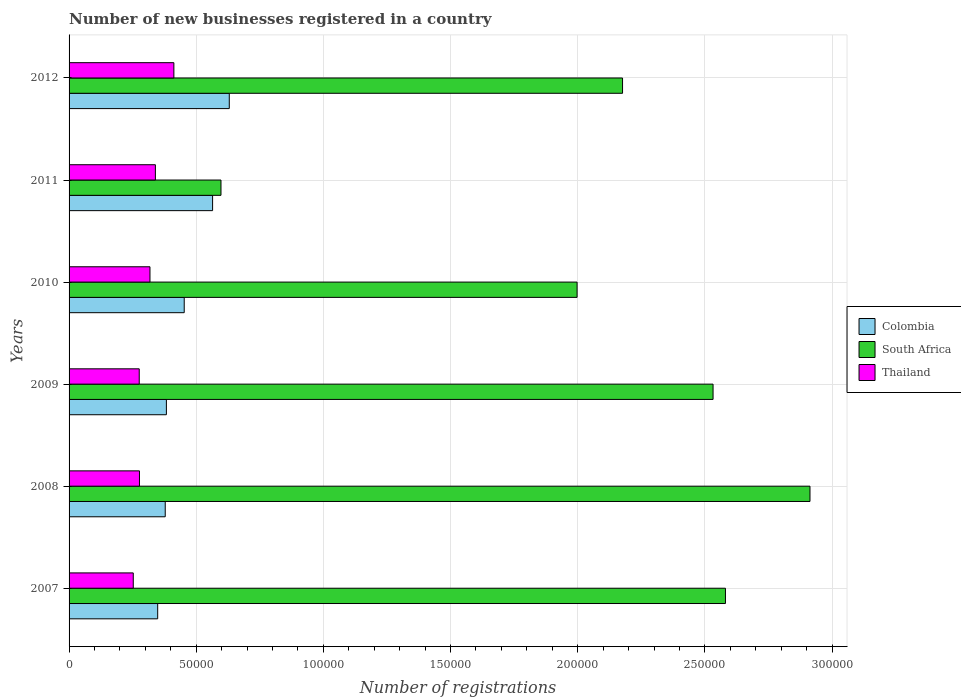Are the number of bars per tick equal to the number of legend labels?
Give a very brief answer. Yes. Are the number of bars on each tick of the Y-axis equal?
Provide a succinct answer. Yes. How many bars are there on the 6th tick from the top?
Your answer should be compact. 3. In how many cases, is the number of bars for a given year not equal to the number of legend labels?
Ensure brevity in your answer.  0. What is the number of new businesses registered in Colombia in 2009?
Provide a succinct answer. 3.83e+04. Across all years, what is the maximum number of new businesses registered in Colombia?
Provide a short and direct response. 6.30e+04. Across all years, what is the minimum number of new businesses registered in Thailand?
Make the answer very short. 2.52e+04. In which year was the number of new businesses registered in South Africa maximum?
Ensure brevity in your answer.  2008. What is the total number of new businesses registered in South Africa in the graph?
Give a very brief answer. 1.28e+06. What is the difference between the number of new businesses registered in Colombia in 2008 and that in 2012?
Your answer should be compact. -2.52e+04. What is the difference between the number of new businesses registered in Colombia in 2010 and the number of new businesses registered in Thailand in 2011?
Your answer should be compact. 1.13e+04. What is the average number of new businesses registered in South Africa per year?
Keep it short and to the point. 2.13e+05. In the year 2007, what is the difference between the number of new businesses registered in Thailand and number of new businesses registered in Colombia?
Offer a very short reply. -9602. What is the ratio of the number of new businesses registered in South Africa in 2010 to that in 2011?
Your answer should be compact. 3.34. Is the number of new businesses registered in South Africa in 2009 less than that in 2011?
Give a very brief answer. No. What is the difference between the highest and the second highest number of new businesses registered in South Africa?
Your answer should be very brief. 3.32e+04. What is the difference between the highest and the lowest number of new businesses registered in Colombia?
Provide a short and direct response. 2.82e+04. In how many years, is the number of new businesses registered in Colombia greater than the average number of new businesses registered in Colombia taken over all years?
Offer a terse response. 2. What does the 1st bar from the top in 2012 represents?
Provide a short and direct response. Thailand. What does the 1st bar from the bottom in 2012 represents?
Provide a succinct answer. Colombia. What is the difference between two consecutive major ticks on the X-axis?
Keep it short and to the point. 5.00e+04. Does the graph contain any zero values?
Make the answer very short. No. Does the graph contain grids?
Give a very brief answer. Yes. How are the legend labels stacked?
Give a very brief answer. Vertical. What is the title of the graph?
Make the answer very short. Number of new businesses registered in a country. Does "Comoros" appear as one of the legend labels in the graph?
Make the answer very short. No. What is the label or title of the X-axis?
Your answer should be compact. Number of registrations. What is the Number of registrations of Colombia in 2007?
Provide a succinct answer. 3.48e+04. What is the Number of registrations of South Africa in 2007?
Give a very brief answer. 2.58e+05. What is the Number of registrations in Thailand in 2007?
Your response must be concise. 2.52e+04. What is the Number of registrations of Colombia in 2008?
Provide a succinct answer. 3.78e+04. What is the Number of registrations of South Africa in 2008?
Your answer should be compact. 2.91e+05. What is the Number of registrations in Thailand in 2008?
Your answer should be compact. 2.77e+04. What is the Number of registrations in Colombia in 2009?
Ensure brevity in your answer.  3.83e+04. What is the Number of registrations in South Africa in 2009?
Your answer should be compact. 2.53e+05. What is the Number of registrations of Thailand in 2009?
Your answer should be very brief. 2.76e+04. What is the Number of registrations in Colombia in 2010?
Your answer should be very brief. 4.53e+04. What is the Number of registrations in South Africa in 2010?
Your response must be concise. 2.00e+05. What is the Number of registrations of Thailand in 2010?
Provide a short and direct response. 3.18e+04. What is the Number of registrations of Colombia in 2011?
Give a very brief answer. 5.64e+04. What is the Number of registrations of South Africa in 2011?
Ensure brevity in your answer.  5.97e+04. What is the Number of registrations of Thailand in 2011?
Offer a very short reply. 3.39e+04. What is the Number of registrations of Colombia in 2012?
Keep it short and to the point. 6.30e+04. What is the Number of registrations in South Africa in 2012?
Make the answer very short. 2.18e+05. What is the Number of registrations of Thailand in 2012?
Your answer should be very brief. 4.12e+04. Across all years, what is the maximum Number of registrations of Colombia?
Offer a terse response. 6.30e+04. Across all years, what is the maximum Number of registrations in South Africa?
Your answer should be compact. 2.91e+05. Across all years, what is the maximum Number of registrations in Thailand?
Your answer should be very brief. 4.12e+04. Across all years, what is the minimum Number of registrations of Colombia?
Your answer should be very brief. 3.48e+04. Across all years, what is the minimum Number of registrations of South Africa?
Keep it short and to the point. 5.97e+04. Across all years, what is the minimum Number of registrations of Thailand?
Ensure brevity in your answer.  2.52e+04. What is the total Number of registrations in Colombia in the graph?
Make the answer very short. 2.76e+05. What is the total Number of registrations in South Africa in the graph?
Your response must be concise. 1.28e+06. What is the total Number of registrations in Thailand in the graph?
Ensure brevity in your answer.  1.87e+05. What is the difference between the Number of registrations in Colombia in 2007 and that in 2008?
Your answer should be very brief. -2967. What is the difference between the Number of registrations in South Africa in 2007 and that in 2008?
Give a very brief answer. -3.32e+04. What is the difference between the Number of registrations of Thailand in 2007 and that in 2008?
Your answer should be compact. -2439. What is the difference between the Number of registrations of Colombia in 2007 and that in 2009?
Offer a very short reply. -3422. What is the difference between the Number of registrations of South Africa in 2007 and that in 2009?
Provide a succinct answer. 4874. What is the difference between the Number of registrations of Thailand in 2007 and that in 2009?
Your response must be concise. -2346. What is the difference between the Number of registrations of Colombia in 2007 and that in 2010?
Your response must be concise. -1.04e+04. What is the difference between the Number of registrations in South Africa in 2007 and that in 2010?
Offer a very short reply. 5.83e+04. What is the difference between the Number of registrations of Thailand in 2007 and that in 2010?
Ensure brevity in your answer.  -6565. What is the difference between the Number of registrations in Colombia in 2007 and that in 2011?
Ensure brevity in your answer.  -2.16e+04. What is the difference between the Number of registrations in South Africa in 2007 and that in 2011?
Offer a very short reply. 1.98e+05. What is the difference between the Number of registrations of Thailand in 2007 and that in 2011?
Keep it short and to the point. -8699. What is the difference between the Number of registrations of Colombia in 2007 and that in 2012?
Your answer should be compact. -2.82e+04. What is the difference between the Number of registrations of South Africa in 2007 and that in 2012?
Offer a terse response. 4.05e+04. What is the difference between the Number of registrations in Thailand in 2007 and that in 2012?
Provide a succinct answer. -1.60e+04. What is the difference between the Number of registrations in Colombia in 2008 and that in 2009?
Keep it short and to the point. -455. What is the difference between the Number of registrations of South Africa in 2008 and that in 2009?
Give a very brief answer. 3.81e+04. What is the difference between the Number of registrations in Thailand in 2008 and that in 2009?
Provide a succinct answer. 93. What is the difference between the Number of registrations in Colombia in 2008 and that in 2010?
Your response must be concise. -7463. What is the difference between the Number of registrations in South Africa in 2008 and that in 2010?
Your response must be concise. 9.16e+04. What is the difference between the Number of registrations in Thailand in 2008 and that in 2010?
Offer a terse response. -4126. What is the difference between the Number of registrations of Colombia in 2008 and that in 2011?
Ensure brevity in your answer.  -1.86e+04. What is the difference between the Number of registrations of South Africa in 2008 and that in 2011?
Your answer should be compact. 2.32e+05. What is the difference between the Number of registrations of Thailand in 2008 and that in 2011?
Your response must be concise. -6260. What is the difference between the Number of registrations of Colombia in 2008 and that in 2012?
Provide a short and direct response. -2.52e+04. What is the difference between the Number of registrations in South Africa in 2008 and that in 2012?
Your answer should be very brief. 7.37e+04. What is the difference between the Number of registrations in Thailand in 2008 and that in 2012?
Make the answer very short. -1.35e+04. What is the difference between the Number of registrations in Colombia in 2009 and that in 2010?
Offer a very short reply. -7008. What is the difference between the Number of registrations of South Africa in 2009 and that in 2010?
Ensure brevity in your answer.  5.35e+04. What is the difference between the Number of registrations of Thailand in 2009 and that in 2010?
Ensure brevity in your answer.  -4219. What is the difference between the Number of registrations of Colombia in 2009 and that in 2011?
Offer a terse response. -1.82e+04. What is the difference between the Number of registrations in South Africa in 2009 and that in 2011?
Offer a terse response. 1.93e+05. What is the difference between the Number of registrations in Thailand in 2009 and that in 2011?
Provide a short and direct response. -6353. What is the difference between the Number of registrations in Colombia in 2009 and that in 2012?
Your answer should be compact. -2.47e+04. What is the difference between the Number of registrations in South Africa in 2009 and that in 2012?
Keep it short and to the point. 3.56e+04. What is the difference between the Number of registrations in Thailand in 2009 and that in 2012?
Offer a very short reply. -1.36e+04. What is the difference between the Number of registrations of Colombia in 2010 and that in 2011?
Your answer should be compact. -1.12e+04. What is the difference between the Number of registrations of South Africa in 2010 and that in 2011?
Ensure brevity in your answer.  1.40e+05. What is the difference between the Number of registrations of Thailand in 2010 and that in 2011?
Keep it short and to the point. -2134. What is the difference between the Number of registrations in Colombia in 2010 and that in 2012?
Your answer should be compact. -1.77e+04. What is the difference between the Number of registrations of South Africa in 2010 and that in 2012?
Your answer should be compact. -1.79e+04. What is the difference between the Number of registrations of Thailand in 2010 and that in 2012?
Your answer should be compact. -9404. What is the difference between the Number of registrations in Colombia in 2011 and that in 2012?
Offer a terse response. -6559. What is the difference between the Number of registrations of South Africa in 2011 and that in 2012?
Ensure brevity in your answer.  -1.58e+05. What is the difference between the Number of registrations in Thailand in 2011 and that in 2012?
Your answer should be very brief. -7270. What is the difference between the Number of registrations of Colombia in 2007 and the Number of registrations of South Africa in 2008?
Your answer should be compact. -2.56e+05. What is the difference between the Number of registrations of Colombia in 2007 and the Number of registrations of Thailand in 2008?
Offer a terse response. 7163. What is the difference between the Number of registrations of South Africa in 2007 and the Number of registrations of Thailand in 2008?
Provide a short and direct response. 2.30e+05. What is the difference between the Number of registrations in Colombia in 2007 and the Number of registrations in South Africa in 2009?
Give a very brief answer. -2.18e+05. What is the difference between the Number of registrations in Colombia in 2007 and the Number of registrations in Thailand in 2009?
Your response must be concise. 7256. What is the difference between the Number of registrations of South Africa in 2007 and the Number of registrations of Thailand in 2009?
Your answer should be compact. 2.31e+05. What is the difference between the Number of registrations of Colombia in 2007 and the Number of registrations of South Africa in 2010?
Make the answer very short. -1.65e+05. What is the difference between the Number of registrations of Colombia in 2007 and the Number of registrations of Thailand in 2010?
Give a very brief answer. 3037. What is the difference between the Number of registrations in South Africa in 2007 and the Number of registrations in Thailand in 2010?
Provide a short and direct response. 2.26e+05. What is the difference between the Number of registrations of Colombia in 2007 and the Number of registrations of South Africa in 2011?
Your answer should be very brief. -2.49e+04. What is the difference between the Number of registrations in Colombia in 2007 and the Number of registrations in Thailand in 2011?
Offer a very short reply. 903. What is the difference between the Number of registrations of South Africa in 2007 and the Number of registrations of Thailand in 2011?
Make the answer very short. 2.24e+05. What is the difference between the Number of registrations of Colombia in 2007 and the Number of registrations of South Africa in 2012?
Keep it short and to the point. -1.83e+05. What is the difference between the Number of registrations in Colombia in 2007 and the Number of registrations in Thailand in 2012?
Your answer should be compact. -6367. What is the difference between the Number of registrations in South Africa in 2007 and the Number of registrations in Thailand in 2012?
Your answer should be compact. 2.17e+05. What is the difference between the Number of registrations of Colombia in 2008 and the Number of registrations of South Africa in 2009?
Provide a short and direct response. -2.15e+05. What is the difference between the Number of registrations of Colombia in 2008 and the Number of registrations of Thailand in 2009?
Your response must be concise. 1.02e+04. What is the difference between the Number of registrations of South Africa in 2008 and the Number of registrations of Thailand in 2009?
Your response must be concise. 2.64e+05. What is the difference between the Number of registrations in Colombia in 2008 and the Number of registrations in South Africa in 2010?
Your answer should be compact. -1.62e+05. What is the difference between the Number of registrations of Colombia in 2008 and the Number of registrations of Thailand in 2010?
Make the answer very short. 6004. What is the difference between the Number of registrations in South Africa in 2008 and the Number of registrations in Thailand in 2010?
Offer a terse response. 2.60e+05. What is the difference between the Number of registrations of Colombia in 2008 and the Number of registrations of South Africa in 2011?
Provide a succinct answer. -2.19e+04. What is the difference between the Number of registrations in Colombia in 2008 and the Number of registrations in Thailand in 2011?
Offer a terse response. 3870. What is the difference between the Number of registrations of South Africa in 2008 and the Number of registrations of Thailand in 2011?
Give a very brief answer. 2.57e+05. What is the difference between the Number of registrations in Colombia in 2008 and the Number of registrations in South Africa in 2012?
Offer a terse response. -1.80e+05. What is the difference between the Number of registrations in Colombia in 2008 and the Number of registrations in Thailand in 2012?
Offer a very short reply. -3400. What is the difference between the Number of registrations in South Africa in 2008 and the Number of registrations in Thailand in 2012?
Keep it short and to the point. 2.50e+05. What is the difference between the Number of registrations of Colombia in 2009 and the Number of registrations of South Africa in 2010?
Your answer should be compact. -1.61e+05. What is the difference between the Number of registrations of Colombia in 2009 and the Number of registrations of Thailand in 2010?
Ensure brevity in your answer.  6459. What is the difference between the Number of registrations of South Africa in 2009 and the Number of registrations of Thailand in 2010?
Keep it short and to the point. 2.21e+05. What is the difference between the Number of registrations in Colombia in 2009 and the Number of registrations in South Africa in 2011?
Your answer should be compact. -2.15e+04. What is the difference between the Number of registrations in Colombia in 2009 and the Number of registrations in Thailand in 2011?
Provide a short and direct response. 4325. What is the difference between the Number of registrations of South Africa in 2009 and the Number of registrations of Thailand in 2011?
Offer a terse response. 2.19e+05. What is the difference between the Number of registrations of Colombia in 2009 and the Number of registrations of South Africa in 2012?
Provide a succinct answer. -1.79e+05. What is the difference between the Number of registrations of Colombia in 2009 and the Number of registrations of Thailand in 2012?
Keep it short and to the point. -2945. What is the difference between the Number of registrations in South Africa in 2009 and the Number of registrations in Thailand in 2012?
Ensure brevity in your answer.  2.12e+05. What is the difference between the Number of registrations of Colombia in 2010 and the Number of registrations of South Africa in 2011?
Make the answer very short. -1.45e+04. What is the difference between the Number of registrations in Colombia in 2010 and the Number of registrations in Thailand in 2011?
Give a very brief answer. 1.13e+04. What is the difference between the Number of registrations in South Africa in 2010 and the Number of registrations in Thailand in 2011?
Provide a short and direct response. 1.66e+05. What is the difference between the Number of registrations in Colombia in 2010 and the Number of registrations in South Africa in 2012?
Your answer should be very brief. -1.72e+05. What is the difference between the Number of registrations of Colombia in 2010 and the Number of registrations of Thailand in 2012?
Provide a short and direct response. 4063. What is the difference between the Number of registrations in South Africa in 2010 and the Number of registrations in Thailand in 2012?
Make the answer very short. 1.59e+05. What is the difference between the Number of registrations of Colombia in 2011 and the Number of registrations of South Africa in 2012?
Your response must be concise. -1.61e+05. What is the difference between the Number of registrations in Colombia in 2011 and the Number of registrations in Thailand in 2012?
Keep it short and to the point. 1.52e+04. What is the difference between the Number of registrations in South Africa in 2011 and the Number of registrations in Thailand in 2012?
Ensure brevity in your answer.  1.85e+04. What is the average Number of registrations in Colombia per year?
Give a very brief answer. 4.59e+04. What is the average Number of registrations in South Africa per year?
Your response must be concise. 2.13e+05. What is the average Number of registrations in Thailand per year?
Provide a succinct answer. 3.12e+04. In the year 2007, what is the difference between the Number of registrations of Colombia and Number of registrations of South Africa?
Your response must be concise. -2.23e+05. In the year 2007, what is the difference between the Number of registrations in Colombia and Number of registrations in Thailand?
Provide a succinct answer. 9602. In the year 2007, what is the difference between the Number of registrations in South Africa and Number of registrations in Thailand?
Provide a short and direct response. 2.33e+05. In the year 2008, what is the difference between the Number of registrations in Colombia and Number of registrations in South Africa?
Provide a succinct answer. -2.54e+05. In the year 2008, what is the difference between the Number of registrations of Colombia and Number of registrations of Thailand?
Your answer should be very brief. 1.01e+04. In the year 2008, what is the difference between the Number of registrations of South Africa and Number of registrations of Thailand?
Your response must be concise. 2.64e+05. In the year 2009, what is the difference between the Number of registrations of Colombia and Number of registrations of South Africa?
Ensure brevity in your answer.  -2.15e+05. In the year 2009, what is the difference between the Number of registrations of Colombia and Number of registrations of Thailand?
Keep it short and to the point. 1.07e+04. In the year 2009, what is the difference between the Number of registrations in South Africa and Number of registrations in Thailand?
Your answer should be very brief. 2.26e+05. In the year 2010, what is the difference between the Number of registrations of Colombia and Number of registrations of South Africa?
Provide a succinct answer. -1.54e+05. In the year 2010, what is the difference between the Number of registrations in Colombia and Number of registrations in Thailand?
Offer a very short reply. 1.35e+04. In the year 2010, what is the difference between the Number of registrations in South Africa and Number of registrations in Thailand?
Provide a succinct answer. 1.68e+05. In the year 2011, what is the difference between the Number of registrations in Colombia and Number of registrations in South Africa?
Your answer should be very brief. -3297. In the year 2011, what is the difference between the Number of registrations of Colombia and Number of registrations of Thailand?
Offer a very short reply. 2.25e+04. In the year 2011, what is the difference between the Number of registrations of South Africa and Number of registrations of Thailand?
Your answer should be very brief. 2.58e+04. In the year 2012, what is the difference between the Number of registrations in Colombia and Number of registrations in South Africa?
Provide a succinct answer. -1.55e+05. In the year 2012, what is the difference between the Number of registrations of Colombia and Number of registrations of Thailand?
Your response must be concise. 2.18e+04. In the year 2012, what is the difference between the Number of registrations in South Africa and Number of registrations in Thailand?
Keep it short and to the point. 1.76e+05. What is the ratio of the Number of registrations of Colombia in 2007 to that in 2008?
Your answer should be very brief. 0.92. What is the ratio of the Number of registrations of South Africa in 2007 to that in 2008?
Your response must be concise. 0.89. What is the ratio of the Number of registrations of Thailand in 2007 to that in 2008?
Ensure brevity in your answer.  0.91. What is the ratio of the Number of registrations of Colombia in 2007 to that in 2009?
Your answer should be compact. 0.91. What is the ratio of the Number of registrations in South Africa in 2007 to that in 2009?
Your answer should be very brief. 1.02. What is the ratio of the Number of registrations in Thailand in 2007 to that in 2009?
Your answer should be compact. 0.92. What is the ratio of the Number of registrations of Colombia in 2007 to that in 2010?
Ensure brevity in your answer.  0.77. What is the ratio of the Number of registrations in South Africa in 2007 to that in 2010?
Provide a short and direct response. 1.29. What is the ratio of the Number of registrations in Thailand in 2007 to that in 2010?
Give a very brief answer. 0.79. What is the ratio of the Number of registrations of Colombia in 2007 to that in 2011?
Ensure brevity in your answer.  0.62. What is the ratio of the Number of registrations in South Africa in 2007 to that in 2011?
Give a very brief answer. 4.32. What is the ratio of the Number of registrations of Thailand in 2007 to that in 2011?
Your answer should be very brief. 0.74. What is the ratio of the Number of registrations of Colombia in 2007 to that in 2012?
Your answer should be compact. 0.55. What is the ratio of the Number of registrations in South Africa in 2007 to that in 2012?
Keep it short and to the point. 1.19. What is the ratio of the Number of registrations in Thailand in 2007 to that in 2012?
Your answer should be very brief. 0.61. What is the ratio of the Number of registrations in South Africa in 2008 to that in 2009?
Keep it short and to the point. 1.15. What is the ratio of the Number of registrations in Thailand in 2008 to that in 2009?
Your answer should be very brief. 1. What is the ratio of the Number of registrations in Colombia in 2008 to that in 2010?
Provide a short and direct response. 0.84. What is the ratio of the Number of registrations of South Africa in 2008 to that in 2010?
Make the answer very short. 1.46. What is the ratio of the Number of registrations of Thailand in 2008 to that in 2010?
Your answer should be compact. 0.87. What is the ratio of the Number of registrations of Colombia in 2008 to that in 2011?
Keep it short and to the point. 0.67. What is the ratio of the Number of registrations of South Africa in 2008 to that in 2011?
Keep it short and to the point. 4.88. What is the ratio of the Number of registrations of Thailand in 2008 to that in 2011?
Your answer should be very brief. 0.82. What is the ratio of the Number of registrations of Colombia in 2008 to that in 2012?
Make the answer very short. 0.6. What is the ratio of the Number of registrations in South Africa in 2008 to that in 2012?
Keep it short and to the point. 1.34. What is the ratio of the Number of registrations in Thailand in 2008 to that in 2012?
Provide a short and direct response. 0.67. What is the ratio of the Number of registrations of Colombia in 2009 to that in 2010?
Offer a very short reply. 0.85. What is the ratio of the Number of registrations in South Africa in 2009 to that in 2010?
Provide a succinct answer. 1.27. What is the ratio of the Number of registrations of Thailand in 2009 to that in 2010?
Offer a very short reply. 0.87. What is the ratio of the Number of registrations of Colombia in 2009 to that in 2011?
Offer a very short reply. 0.68. What is the ratio of the Number of registrations in South Africa in 2009 to that in 2011?
Provide a short and direct response. 4.24. What is the ratio of the Number of registrations in Thailand in 2009 to that in 2011?
Provide a succinct answer. 0.81. What is the ratio of the Number of registrations of Colombia in 2009 to that in 2012?
Give a very brief answer. 0.61. What is the ratio of the Number of registrations in South Africa in 2009 to that in 2012?
Give a very brief answer. 1.16. What is the ratio of the Number of registrations of Thailand in 2009 to that in 2012?
Offer a very short reply. 0.67. What is the ratio of the Number of registrations of Colombia in 2010 to that in 2011?
Give a very brief answer. 0.8. What is the ratio of the Number of registrations in South Africa in 2010 to that in 2011?
Provide a succinct answer. 3.34. What is the ratio of the Number of registrations in Thailand in 2010 to that in 2011?
Your answer should be compact. 0.94. What is the ratio of the Number of registrations in Colombia in 2010 to that in 2012?
Make the answer very short. 0.72. What is the ratio of the Number of registrations in South Africa in 2010 to that in 2012?
Provide a short and direct response. 0.92. What is the ratio of the Number of registrations in Thailand in 2010 to that in 2012?
Your answer should be compact. 0.77. What is the ratio of the Number of registrations of Colombia in 2011 to that in 2012?
Make the answer very short. 0.9. What is the ratio of the Number of registrations in South Africa in 2011 to that in 2012?
Offer a terse response. 0.27. What is the ratio of the Number of registrations of Thailand in 2011 to that in 2012?
Offer a very short reply. 0.82. What is the difference between the highest and the second highest Number of registrations in Colombia?
Provide a succinct answer. 6559. What is the difference between the highest and the second highest Number of registrations in South Africa?
Keep it short and to the point. 3.32e+04. What is the difference between the highest and the second highest Number of registrations of Thailand?
Keep it short and to the point. 7270. What is the difference between the highest and the lowest Number of registrations in Colombia?
Give a very brief answer. 2.82e+04. What is the difference between the highest and the lowest Number of registrations in South Africa?
Offer a terse response. 2.32e+05. What is the difference between the highest and the lowest Number of registrations of Thailand?
Your answer should be very brief. 1.60e+04. 